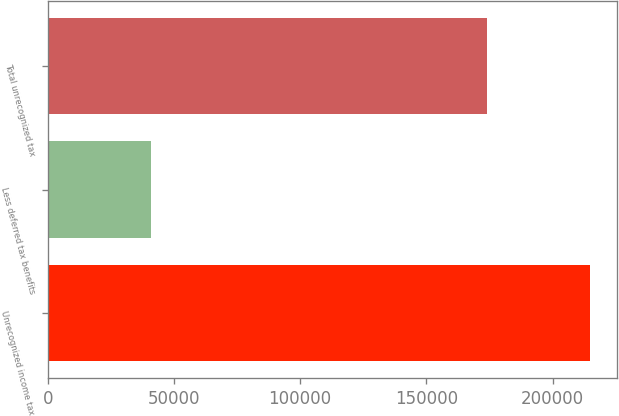Convert chart to OTSL. <chart><loc_0><loc_0><loc_500><loc_500><bar_chart><fcel>Unrecognized income tax<fcel>Less deferred tax benefits<fcel>Total unrecognized tax<nl><fcel>214790<fcel>40862<fcel>173928<nl></chart> 